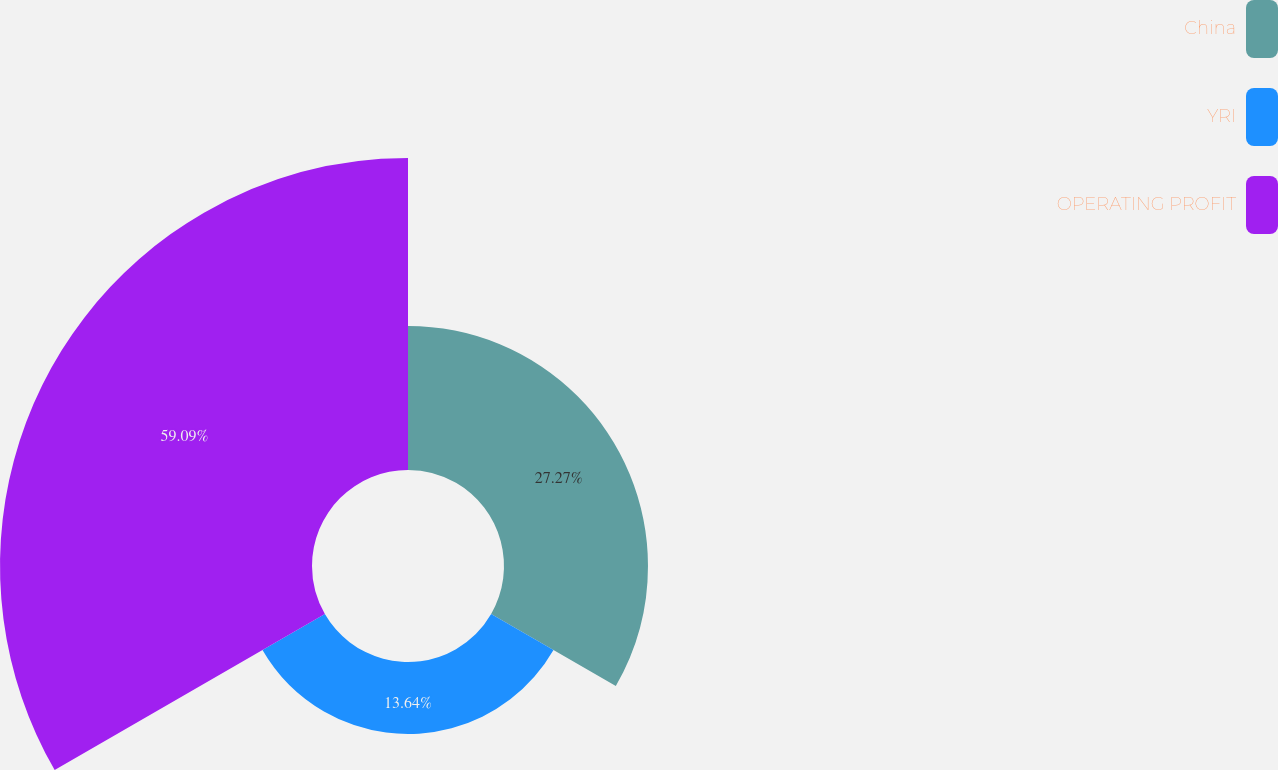Convert chart. <chart><loc_0><loc_0><loc_500><loc_500><pie_chart><fcel>China<fcel>YRI<fcel>OPERATING PROFIT<nl><fcel>27.27%<fcel>13.64%<fcel>59.09%<nl></chart> 